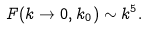Convert formula to latex. <formula><loc_0><loc_0><loc_500><loc_500>F ( k \to 0 , k _ { 0 } ) \sim k ^ { 5 } .</formula> 